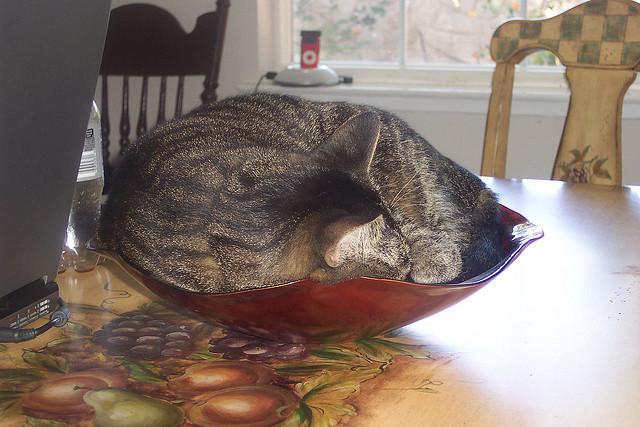Is the cat sleeping?
Short answer required. Yes. What can be seen on the table?
Write a very short answer. Cat. Is this a typical cat bed?
Give a very brief answer. No. 